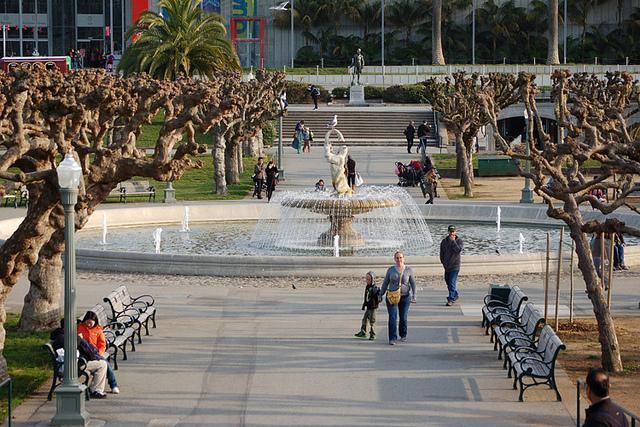How many benches are on the right?
Give a very brief answer. 3. How many people are there?
Give a very brief answer. 2. 